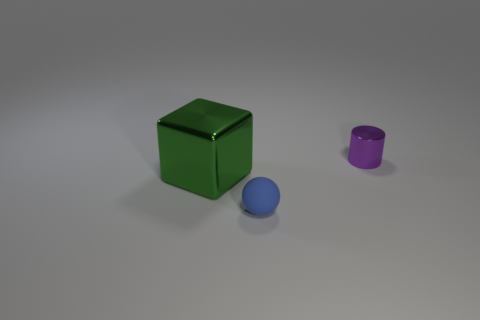Add 2 gray metal cylinders. How many objects exist? 5 Subtract all cubes. How many objects are left? 2 Subtract 0 yellow cylinders. How many objects are left? 3 Subtract all cylinders. Subtract all small blue spheres. How many objects are left? 1 Add 3 rubber things. How many rubber things are left? 4 Add 1 small cyan metallic cubes. How many small cyan metallic cubes exist? 1 